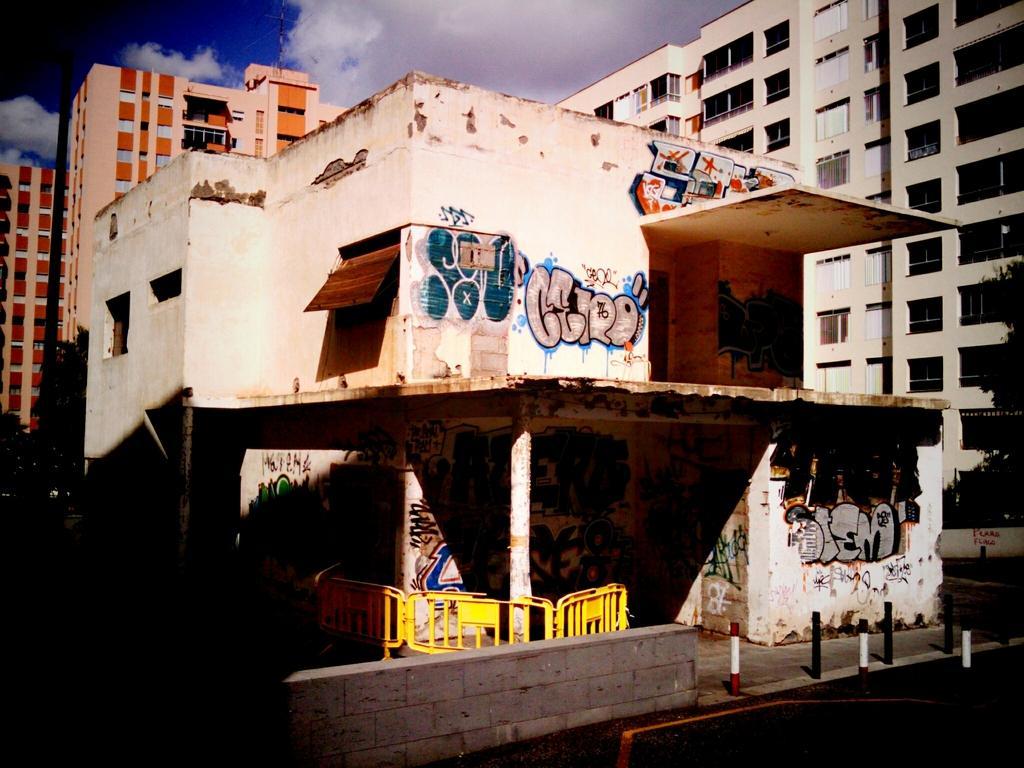In one or two sentences, can you explain what this image depicts? In this image, there are buildings. In front of a building, I can see barricades, a compound wall and there are lane ropes on the road. On the left and right side of the image, there are trees. In the background, I can see the sky. 